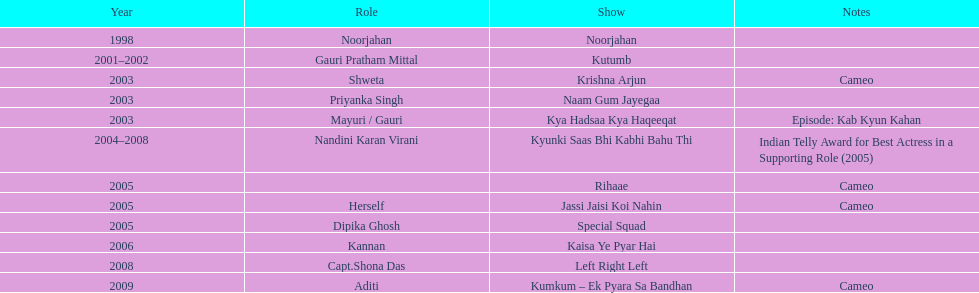How many total television shows has gauri starred in? 12. Parse the table in full. {'header': ['Year', 'Role', 'Show', 'Notes'], 'rows': [['1998', 'Noorjahan', 'Noorjahan', ''], ['2001–2002', 'Gauri Pratham Mittal', 'Kutumb', ''], ['2003', 'Shweta', 'Krishna Arjun', 'Cameo'], ['2003', 'Priyanka Singh', 'Naam Gum Jayegaa', ''], ['2003', 'Mayuri / Gauri', 'Kya Hadsaa Kya Haqeeqat', 'Episode: Kab Kyun Kahan'], ['2004–2008', 'Nandini Karan Virani', 'Kyunki Saas Bhi Kabhi Bahu Thi', 'Indian Telly Award for Best Actress in a Supporting Role (2005)'], ['2005', '', 'Rihaae', 'Cameo'], ['2005', 'Herself', 'Jassi Jaisi Koi Nahin', 'Cameo'], ['2005', 'Dipika Ghosh', 'Special Squad', ''], ['2006', 'Kannan', 'Kaisa Ye Pyar Hai', ''], ['2008', 'Capt.Shona Das', 'Left Right Left', ''], ['2009', 'Aditi', 'Kumkum – Ek Pyara Sa Bandhan', 'Cameo']]} 